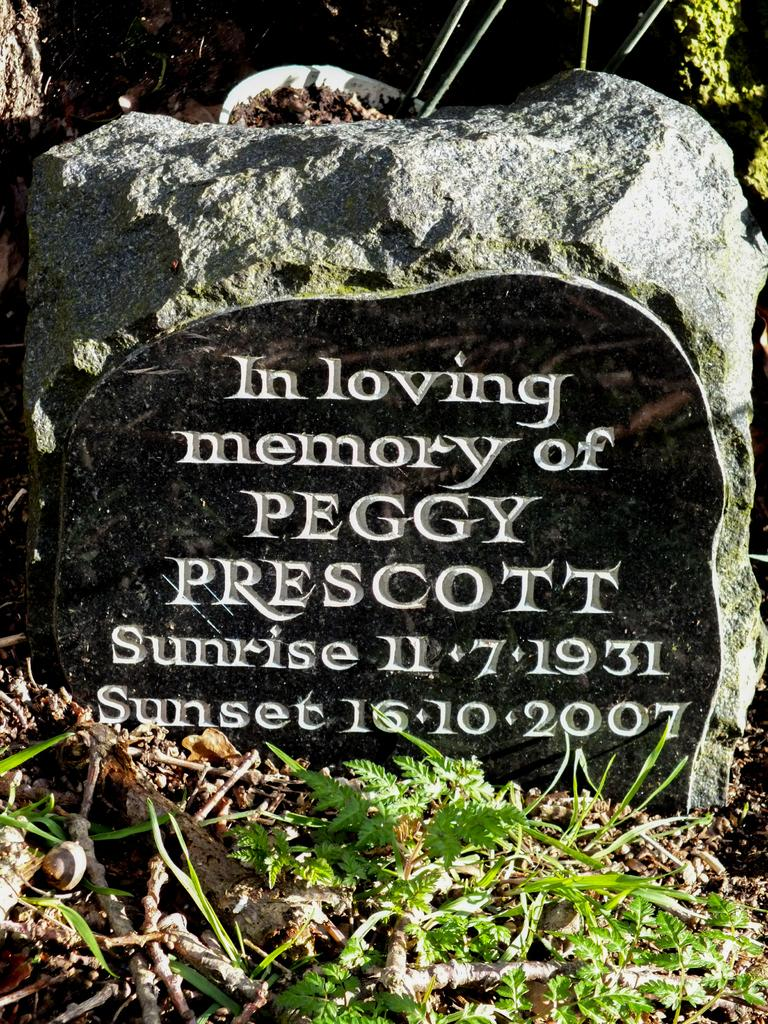What is written or depicted on the stone in the image? There is text present on a stone in the image. What can be seen on the ground in the image? There are dried twigs and small plants on the ground in the image. How many flies can be seen on the frame in the image? There is no frame present in the image, and therefore no flies can be seen on it. Is there a squirrel visible in the image? There is no squirrel present in the image. 